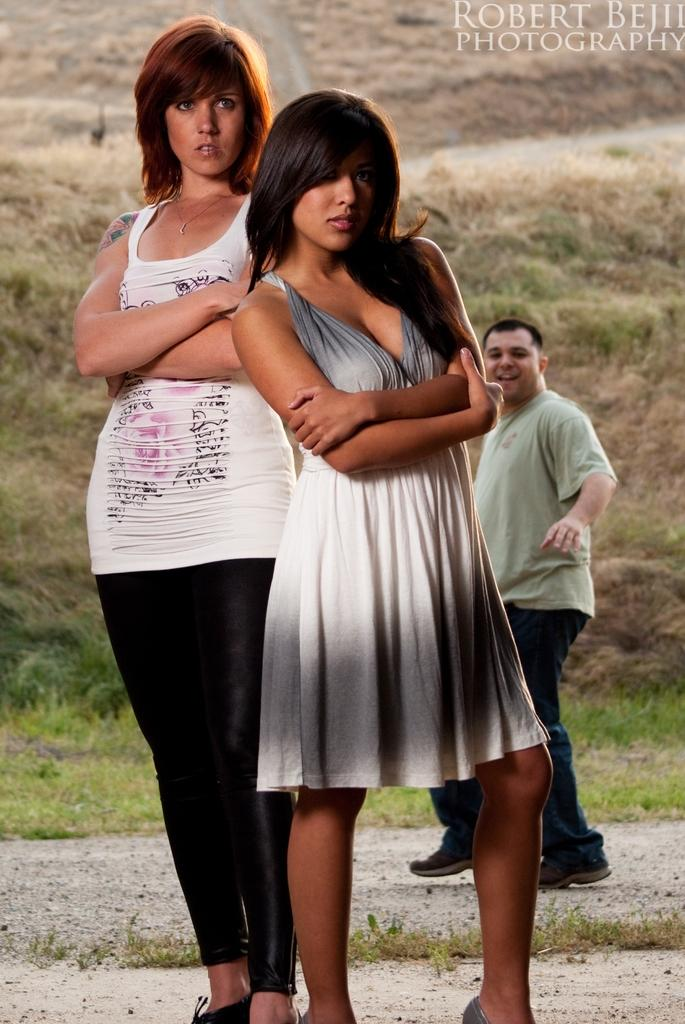What type of visual is shown in the image? The image is a poster. How many people are in the image? There are two women standing in the image, and a man is also present. Where is the man located in the scene? The man is at the back of the scene. What can be seen behind the man? There is grass visible behind the man. Are the two women in the image sisters? There is no information provided about the relationship between the two women in the image. --- Facts: 1. There is a car in the image. 2. The car is red. 3. The car has four wheels. 4. There is a road in the image. 5. The road is paved. Absurd Topics: parrot, sand, ocean Conversation: What is the main subject of the image? The main subject of the image is a car. What color is the car? The car is red. How many wheels does the car have? The car has four wheels. What type of surface is visible in the image? There is a road in the image, and it is paved. Reasoning: Let's think step by step in order to produce the conversation. We start by identifying the main subject of the image, which is the car. Then, we describe the car's color and the number of wheels it has. Finally, we mention the type of surface visible in the image, which is a paved road. Each question is designed to elicit a specific detail about the image that is known from the provided facts. Absurd Question/Answer: Can you see a parrot flying over the car in the image? There is no parrot present in the image. Is the car driving on a sandy beach in the image? The image does not show a sandy beach; it features a paved road. 